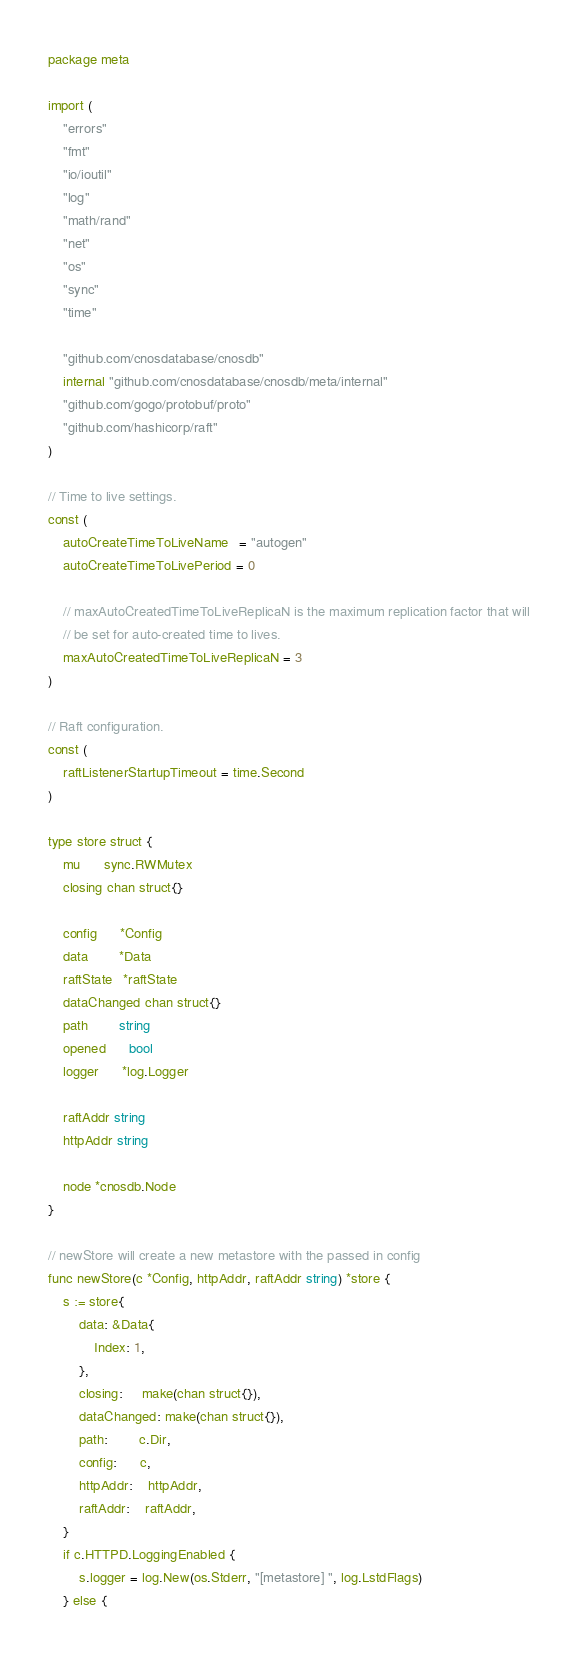<code> <loc_0><loc_0><loc_500><loc_500><_Go_>package meta

import (
	"errors"
	"fmt"
	"io/ioutil"
	"log"
	"math/rand"
	"net"
	"os"
	"sync"
	"time"

	"github.com/cnosdatabase/cnosdb"
	internal "github.com/cnosdatabase/cnosdb/meta/internal"
	"github.com/gogo/protobuf/proto"
	"github.com/hashicorp/raft"
)

// Time to live settings.
const (
	autoCreateTimeToLiveName   = "autogen"
	autoCreateTimeToLivePeriod = 0

	// maxAutoCreatedTimeToLiveReplicaN is the maximum replication factor that will
	// be set for auto-created time to lives.
	maxAutoCreatedTimeToLiveReplicaN = 3
)

// Raft configuration.
const (
	raftListenerStartupTimeout = time.Second
)

type store struct {
	mu      sync.RWMutex
	closing chan struct{}

	config      *Config
	data        *Data
	raftState   *raftState
	dataChanged chan struct{}
	path        string
	opened      bool
	logger      *log.Logger

	raftAddr string
	httpAddr string

	node *cnosdb.Node
}

// newStore will create a new metastore with the passed in config
func newStore(c *Config, httpAddr, raftAddr string) *store {
	s := store{
		data: &Data{
			Index: 1,
		},
		closing:     make(chan struct{}),
		dataChanged: make(chan struct{}),
		path:        c.Dir,
		config:      c,
		httpAddr:    httpAddr,
		raftAddr:    raftAddr,
	}
	if c.HTTPD.LoggingEnabled {
		s.logger = log.New(os.Stderr, "[metastore] ", log.LstdFlags)
	} else {</code> 